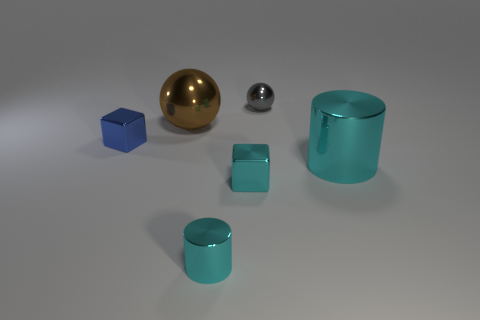There is a tiny shiny thing that is both to the right of the tiny cyan metal cylinder and in front of the blue object; what is its color?
Your answer should be very brief. Cyan. What is the sphere on the left side of the tiny gray object made of?
Offer a very short reply. Metal. Is there a tiny brown shiny object that has the same shape as the large brown metallic object?
Keep it short and to the point. No. How many other things are there of the same shape as the small blue thing?
Offer a terse response. 1. Is the shape of the gray thing the same as the tiny metallic object left of the small cylinder?
Offer a very short reply. No. Is there anything else that has the same material as the big cyan cylinder?
Offer a very short reply. Yes. There is another thing that is the same shape as the small gray thing; what material is it?
Make the answer very short. Metal. What number of small objects are blue things or cyan things?
Make the answer very short. 3. Are there fewer large things in front of the big cylinder than gray objects that are in front of the blue object?
Keep it short and to the point. No. How many things are tiny gray cylinders or small gray metallic objects?
Make the answer very short. 1. 